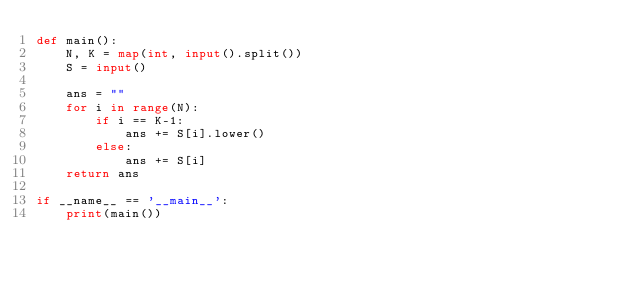Convert code to text. <code><loc_0><loc_0><loc_500><loc_500><_Python_>def main():
    N, K = map(int, input().split())
    S = input()

    ans = ""
    for i in range(N):
        if i == K-1:
            ans += S[i].lower()
        else:
            ans += S[i]
    return ans
    
if __name__ == '__main__':
    print(main())</code> 